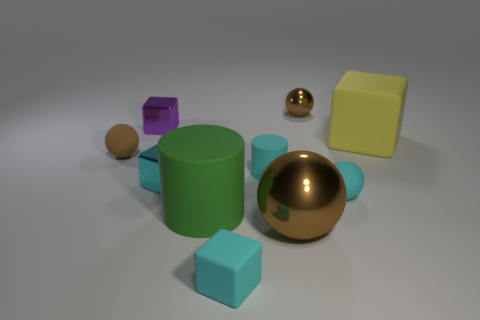Subtract all blue cubes. How many brown spheres are left? 3 Subtract 1 cubes. How many cubes are left? 3 Subtract all green cubes. Subtract all red spheres. How many cubes are left? 4 Subtract all balls. How many objects are left? 6 Subtract all cyan rubber things. Subtract all brown matte objects. How many objects are left? 6 Add 4 cylinders. How many cylinders are left? 6 Add 6 large shiny objects. How many large shiny objects exist? 7 Subtract 0 blue cubes. How many objects are left? 10 